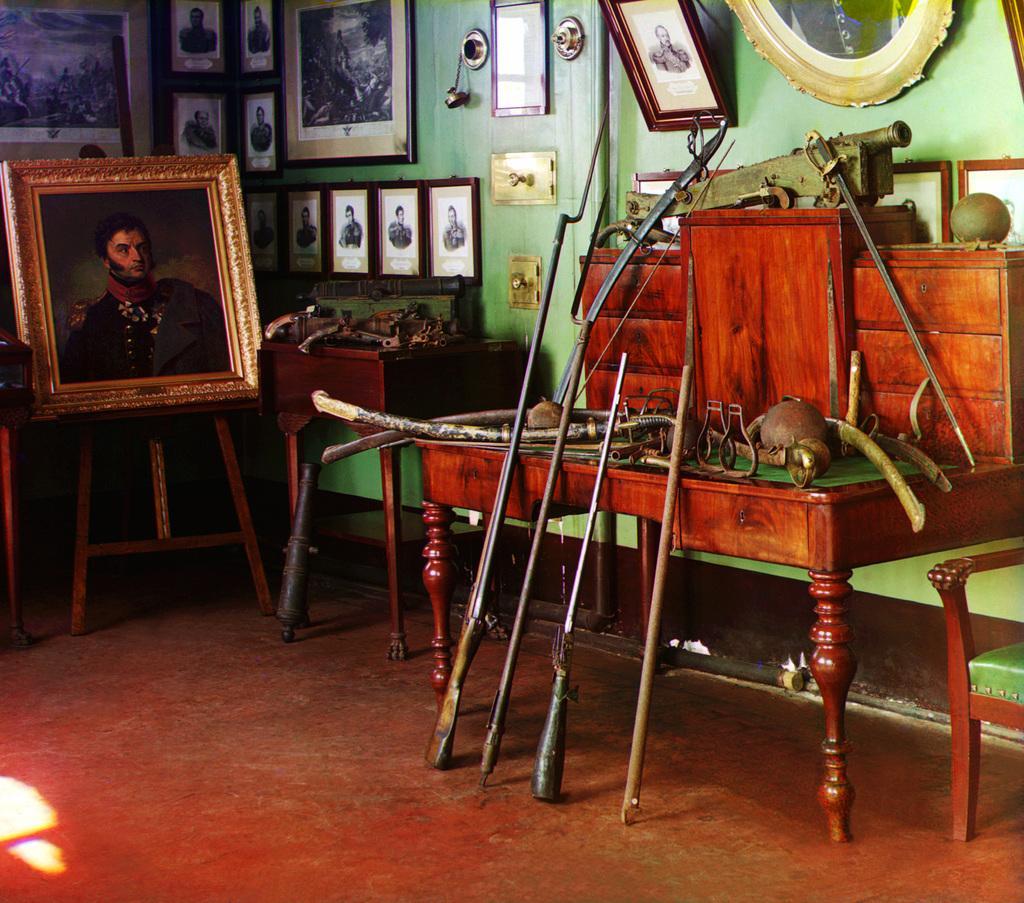Can you describe this image briefly? In can see a photo frame which is placed on a stool. And few photo frames are attached to the wall. this wall is green in color. I can see a table where some historical objects are placed on it. At the right corner of the image I can see a chair. These are the weapons used in olden days. 